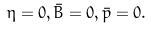<formula> <loc_0><loc_0><loc_500><loc_500>\eta = 0 , \bar { B } = 0 , \bar { p } = 0 .</formula> 